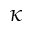<formula> <loc_0><loc_0><loc_500><loc_500>\kappa</formula> 